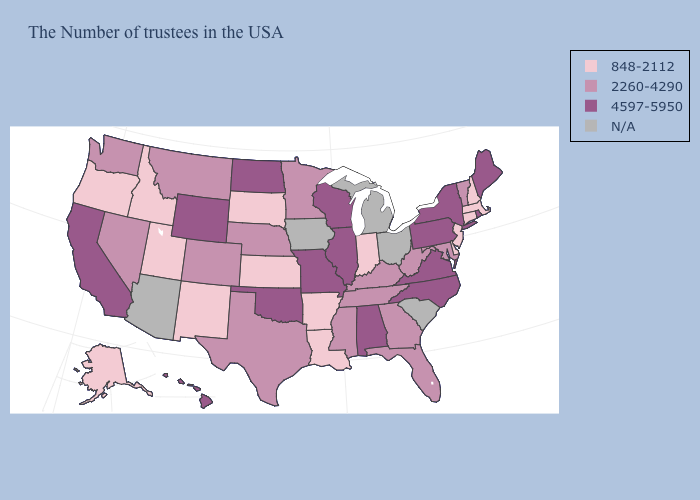What is the highest value in the USA?
Be succinct. 4597-5950. Name the states that have a value in the range N/A?
Keep it brief. South Carolina, Ohio, Michigan, Iowa, Arizona. Name the states that have a value in the range 4597-5950?
Short answer required. Maine, Rhode Island, New York, Pennsylvania, Virginia, North Carolina, Alabama, Wisconsin, Illinois, Missouri, Oklahoma, North Dakota, Wyoming, California, Hawaii. What is the value of Texas?
Answer briefly. 2260-4290. Name the states that have a value in the range 848-2112?
Concise answer only. Massachusetts, New Hampshire, Connecticut, New Jersey, Delaware, Indiana, Louisiana, Arkansas, Kansas, South Dakota, New Mexico, Utah, Idaho, Oregon, Alaska. Name the states that have a value in the range 848-2112?
Answer briefly. Massachusetts, New Hampshire, Connecticut, New Jersey, Delaware, Indiana, Louisiana, Arkansas, Kansas, South Dakota, New Mexico, Utah, Idaho, Oregon, Alaska. What is the highest value in the USA?
Write a very short answer. 4597-5950. Name the states that have a value in the range 848-2112?
Be succinct. Massachusetts, New Hampshire, Connecticut, New Jersey, Delaware, Indiana, Louisiana, Arkansas, Kansas, South Dakota, New Mexico, Utah, Idaho, Oregon, Alaska. What is the highest value in states that border Kentucky?
Give a very brief answer. 4597-5950. Does Tennessee have the lowest value in the USA?
Short answer required. No. Name the states that have a value in the range 2260-4290?
Give a very brief answer. Vermont, Maryland, West Virginia, Florida, Georgia, Kentucky, Tennessee, Mississippi, Minnesota, Nebraska, Texas, Colorado, Montana, Nevada, Washington. What is the value of Utah?
Quick response, please. 848-2112. What is the highest value in the Northeast ?
Concise answer only. 4597-5950. 